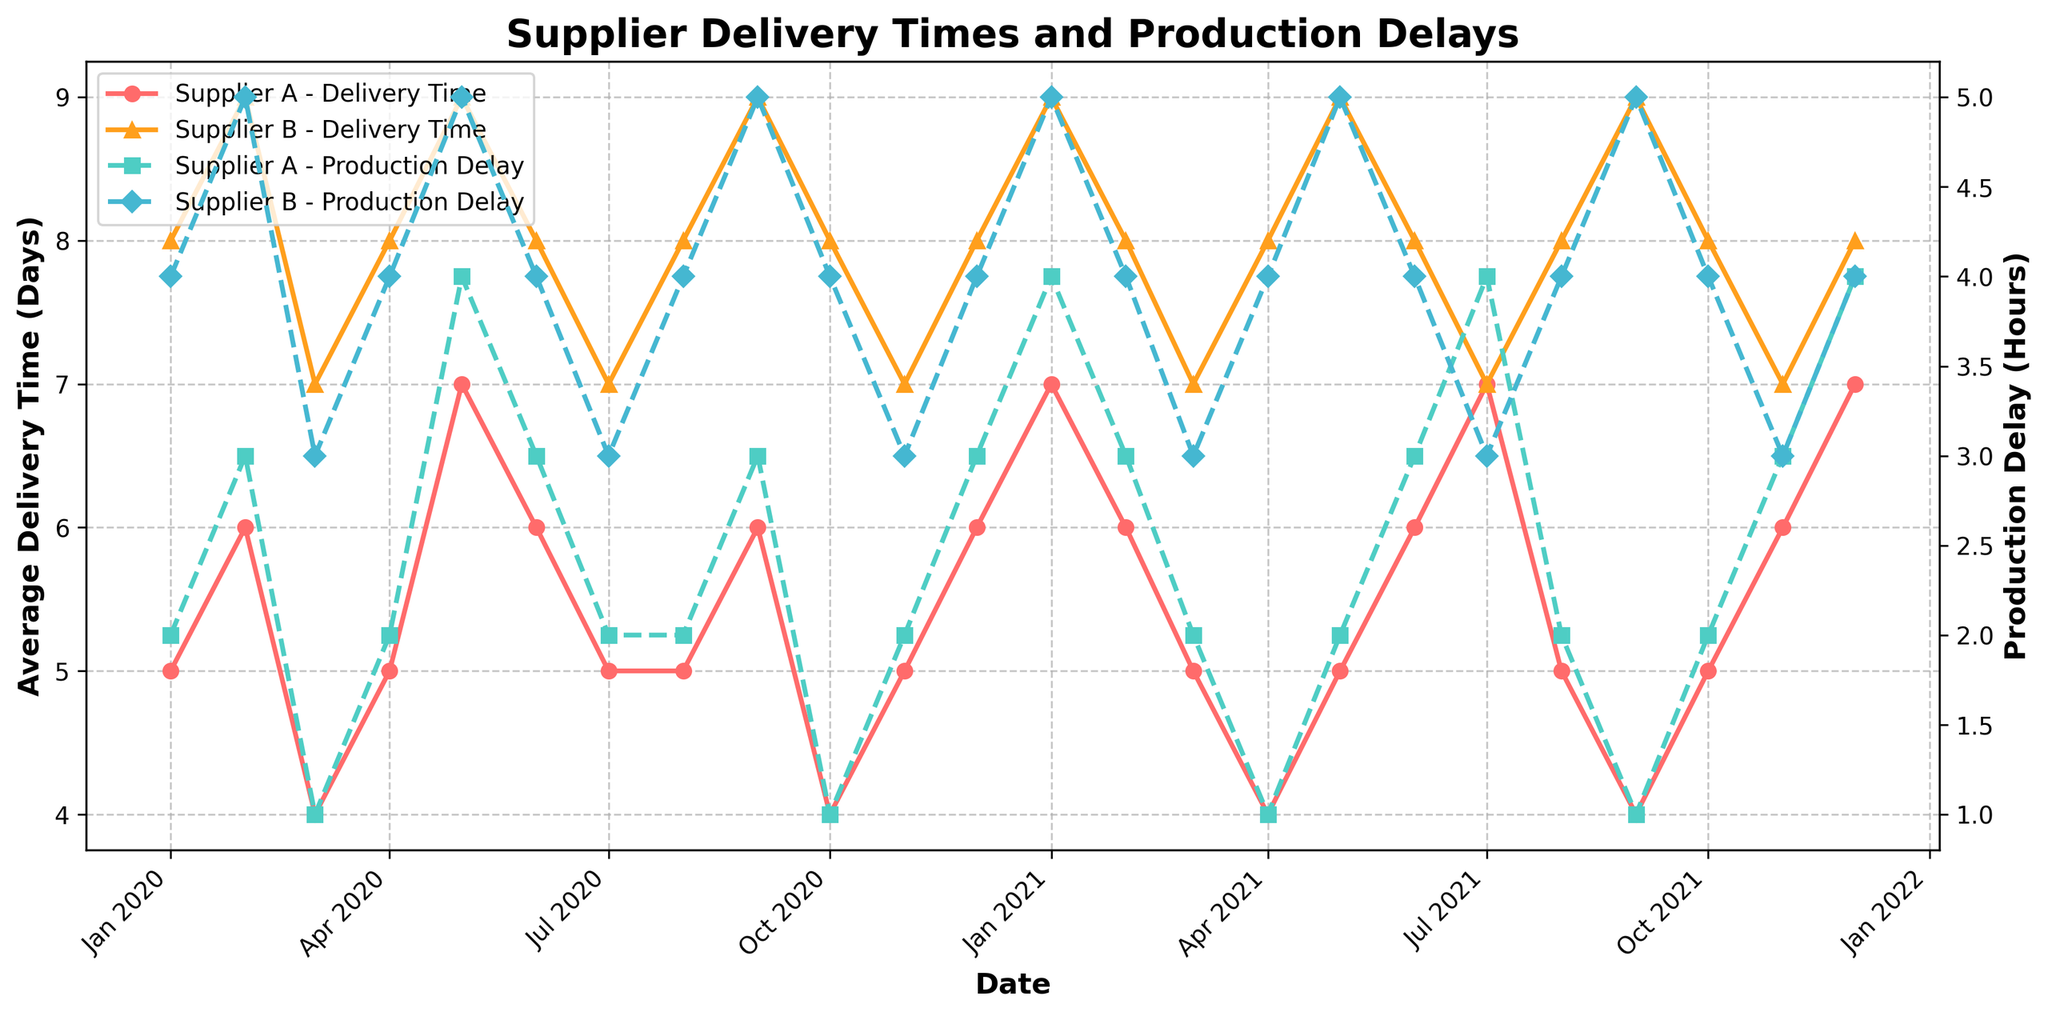What is the average delivery time for Supplier A in January 2020? Look at the plot for January 2020, find the average delivery time for Supplier A. The corresponding value is marked with an "o" marker on the plot. The value is 5 days.
Answer: 5 days Which supplier had the higher delivery time in December 2021? Compare the average delivery times for Supplier A and Supplier B in December 2021. Supplier A's delivery time is 7 days, while Supplier B's delivery time is 8 days.
Answer: Supplier B What is the production delay for Supplier A in July 2021? Locate July 2021 on the x-axis and refer to the line marked with "s" for Supplier A's production delay. The value is 4 hours.
Answer: 4 hours How does the delivery time of Supplier A in January 2020 compare to January 2021? Check the delivery times for Supplier A in both January 2020 and 2021. Both are represented by "o" markers. January 2020 is 5 days and January 2021 is 7 days.
Answer: January 2021 is higher Which month in 2021 showed the lowest delivery time for Supplier B? Examine the delivery times across each month in 2021 for Supplier B. The lowest delivery time is marked with "^". The lowest month is March 2021, with a delivery time of 7 days.
Answer: March 2021 What is the trend in production delay for Supplier B from January 2020 to December 2021? Observe the "D" markers on the plot for Supplier B's production delay. The production delay fluctuates between 3 and 5 hours but generally stays within this range over the two years.
Answer: Fluctuates between 3 and 5 hours For which month and supplier was the highest delivery time recorded in 2020? Identify the highest point in the plot for 2020, considering each supplier separately. Supplier B in May 2020 recorded the highest delivery time of 9 days.
Answer: Supplier B in May 2020 What is the difference in production delay between Supplier A and Supplier B in February 2021? Look at February 2021 for both suppliers. Supplier A's production delay is 3 hours, and Supplier B's delay is 4 hours. The difference is 1 hour.
Answer: 1 hour 